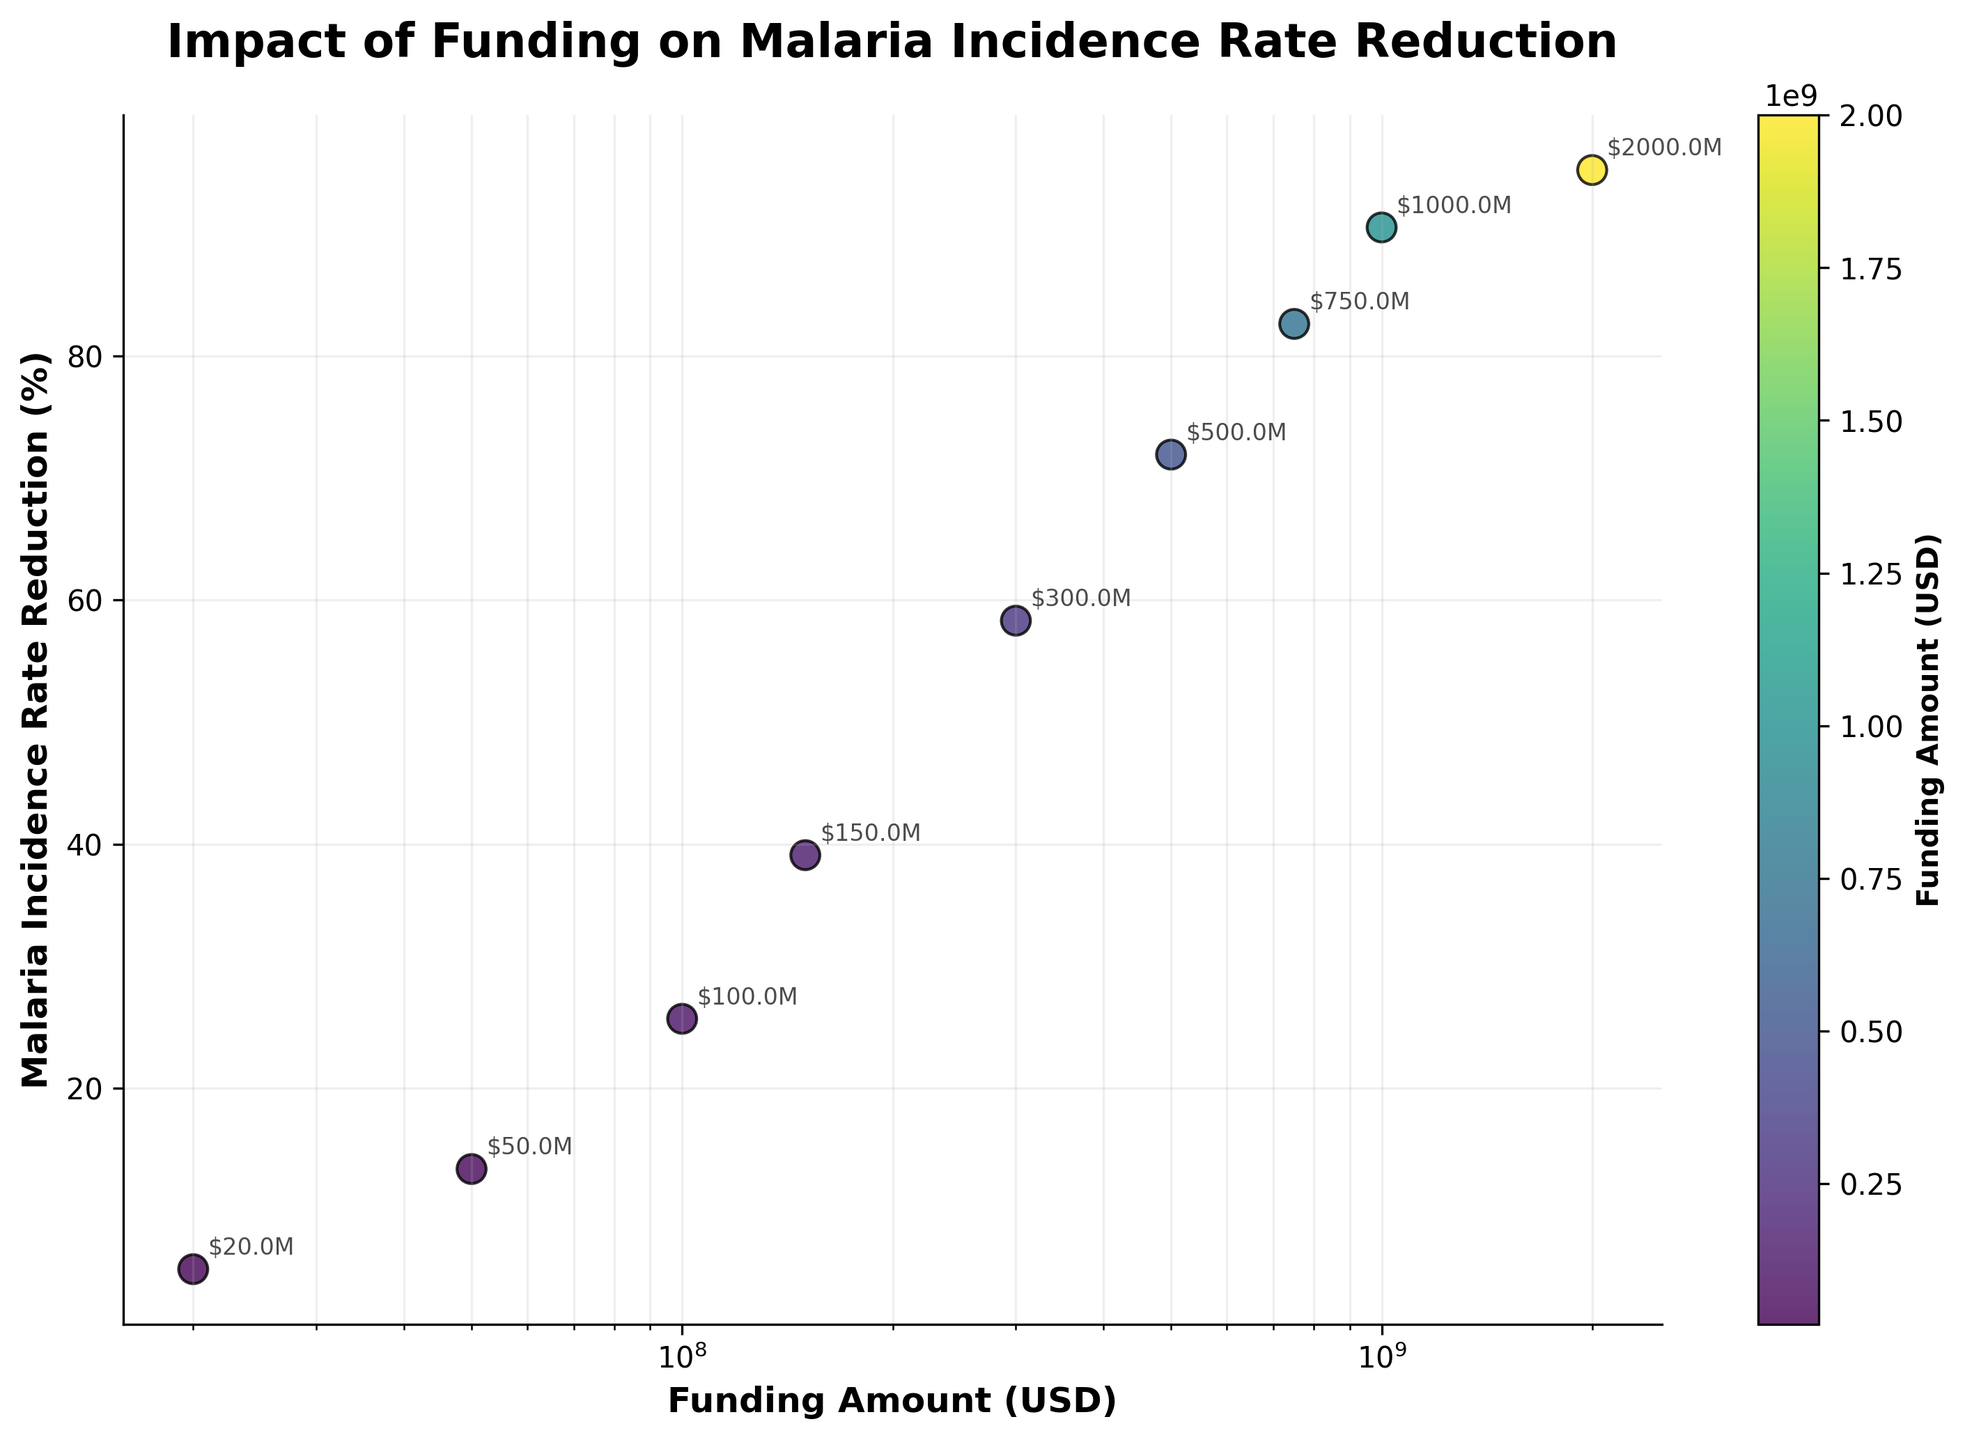What is the title of the figure? The title of the figure is displayed in a bold font at the top and provides the main context or subject of the graph.
Answer: "Impact of Funding on Malaria Incidence Rate Reduction" What is the x-axis label? The x-axis label provides information on what is represented along the horizontal axis of the plot, which in this case is related to funding amounts.
Answer: "Funding Amount (USD)" How many data points are shown in the figure? Each scatter point on the plot represents a data point, which can be counted visually.
Answer: 9 Which data point corresponds to the highest reduction in malaria incidence rates? The highest point on the y-axis denotes the maximum reduction percentage. The corresponding funding amount can be read from the x-axis.
Answer: $2,000,000,000 Which funding amount is associated with a 39.1% reduction in malaria incidence rates? Locate the point on the scatter plot where the y-value is 39.1% and read its corresponding x-value.
Answer: $150,000,000 Is there a positive correlation between funding amounts and reductions in malaria incidence rates? Observe the trend of the points on the scatter plot; if they generally rise from left to right, it implies a positive correlation.
Answer: Yes By how much does the malaria incidence rate reduction increase when the funding amount increases from $200,000,000 to $500,000,000? Find the reductions corresponding to $200,000,000 and $500,000,000, then calculate the difference.
Answer: 71.9% - 58.3% = 13.6% Between which two funding amounts does the largest increase in reduction percentage occur? Examine the differences in malaria incidence rate reductions between each pair of successive funding amounts and identify the largest difference.
Answer: From $300,000,000 to $500,000,000 What color represents the lowest funding amount in the scatter plot? Identify the first (lowest) funding amount on the x-axis and note its color as displayed in the color bar.
Answer: The color indicated in the lower part of the 'viridis' colormap (green) Do the points on the scatter plot suggest any diminishing returns in malaria incidence rate reductions for higher funding amounts? Look for a trend where increases in funding amounts result in smaller incremental reductions in malaria incidence rates over the higher ranges.
Answer: Yes If we double the funding from $500,000,000 to $1,000,000,000, how much does the reduction percentage change? Find the reductions corresponding to $500,000,000 and $1,000,000,000, then calculate the difference.
Answer: 90.5% - 71.9% = 18.6% 